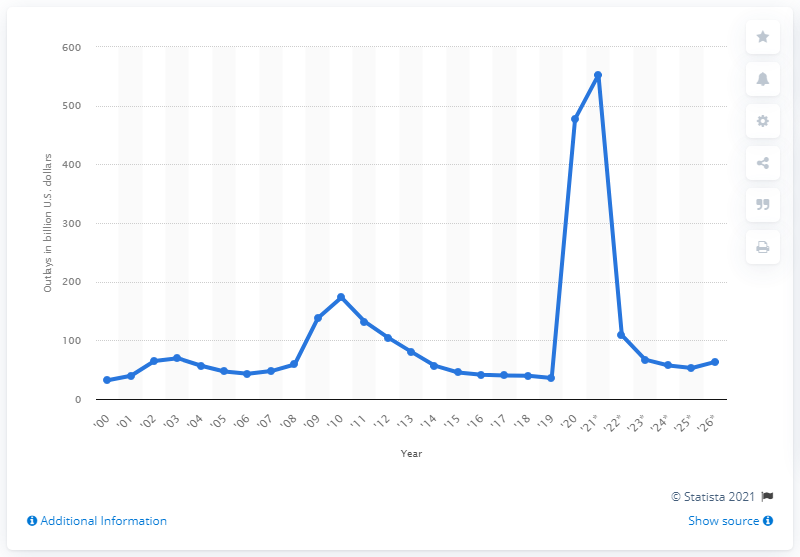Mention a couple of crucial points in this snapshot. The Department of Labor spent approximately $477.53 in 2020. In 2021, the Department of Labor is expected to spend approximately $552.57. 